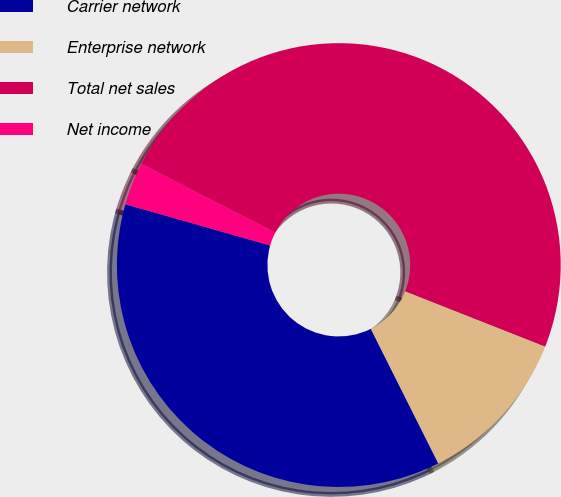<chart> <loc_0><loc_0><loc_500><loc_500><pie_chart><fcel>Carrier network<fcel>Enterprise network<fcel>Total net sales<fcel>Net income<nl><fcel>36.82%<fcel>11.62%<fcel>48.44%<fcel>3.12%<nl></chart> 